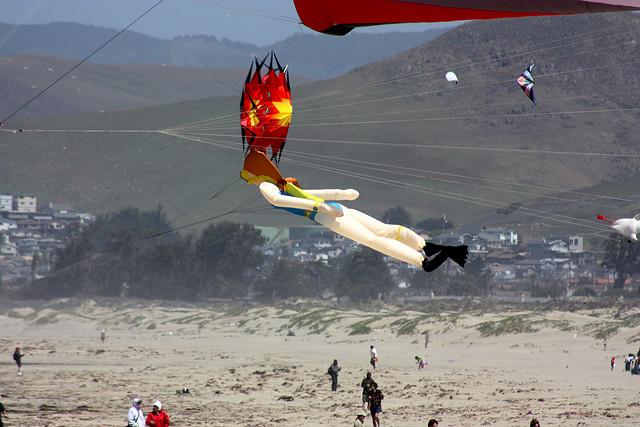If this beach could tell a story, what might it say? The beach would whisper tales of countless sunny days spent in joy and laughter, as families and friends gathered to savor the simple pleasures of life. It would speak of the cool touch of morning fog and the warmth of the midday sun, the rhythmic lullaby of waves caressing its sandy shores. This particular day, it would recount the spectacle of flying kites, the vibrant creations soaring high against the azure canvas, embodying the dreams and imaginations of their makers. From the gentle breezes that carry the kites aloft to the laughter of children running along the water's edge, the beach holds memories of fleeting moments, cherished by all who stroll upon its grains. It bears the timeless narrative of human connection with nature, where every footprint and every kite tethered to the earth tells a story of carefree existence. 